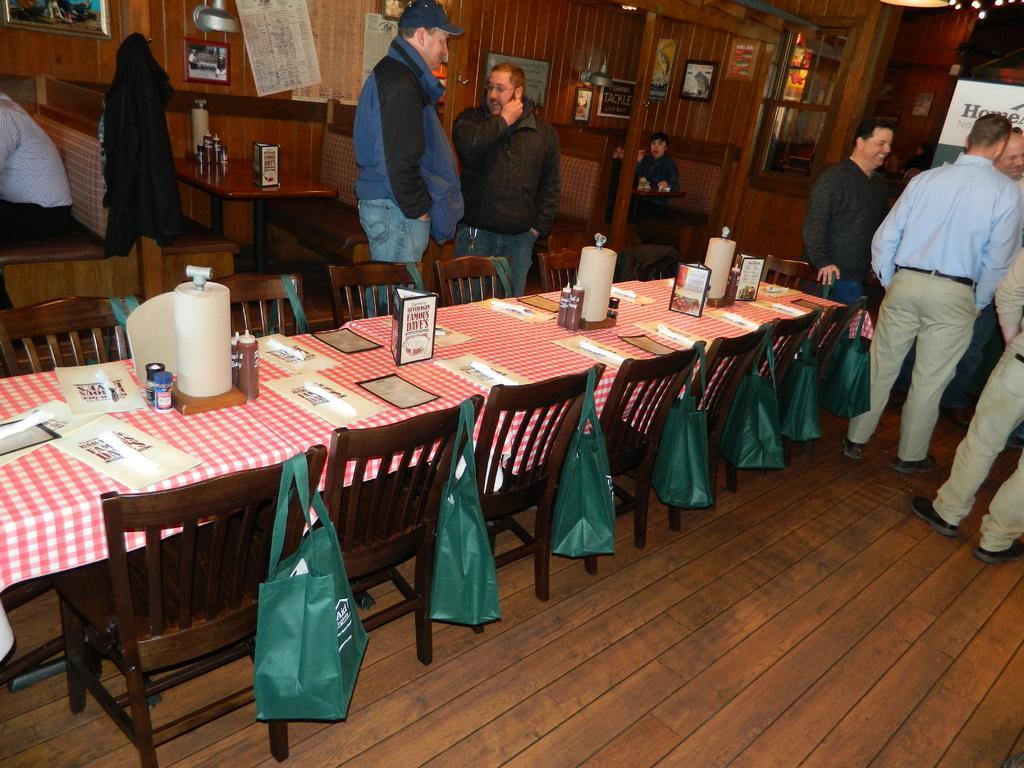Describe this image in one or two sentences. There are group of people standing and there are chairs,table and green bags behind them. 